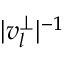<formula> <loc_0><loc_0><loc_500><loc_500>| v _ { l } ^ { \perp } | ^ { - 1 }</formula> 